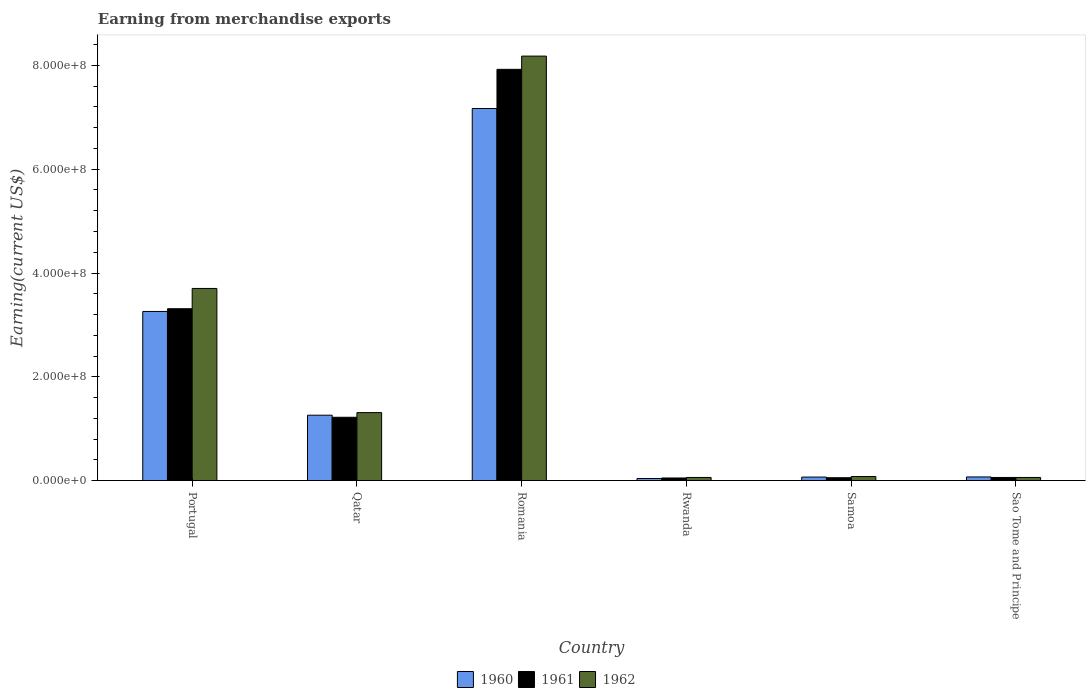How many different coloured bars are there?
Make the answer very short. 3. Are the number of bars per tick equal to the number of legend labels?
Ensure brevity in your answer.  Yes. How many bars are there on the 1st tick from the left?
Offer a very short reply. 3. What is the label of the 2nd group of bars from the left?
Provide a succinct answer. Qatar. What is the amount earned from merchandise exports in 1960 in Sao Tome and Principe?
Provide a succinct answer. 7.00e+06. Across all countries, what is the maximum amount earned from merchandise exports in 1961?
Offer a terse response. 7.92e+08. Across all countries, what is the minimum amount earned from merchandise exports in 1961?
Give a very brief answer. 5.00e+06. In which country was the amount earned from merchandise exports in 1961 maximum?
Provide a short and direct response. Romania. In which country was the amount earned from merchandise exports in 1962 minimum?
Your response must be concise. Rwanda. What is the total amount earned from merchandise exports in 1961 in the graph?
Ensure brevity in your answer.  1.26e+09. What is the difference between the amount earned from merchandise exports in 1961 in Portugal and that in Romania?
Your answer should be very brief. -4.61e+08. What is the difference between the amount earned from merchandise exports in 1961 in Romania and the amount earned from merchandise exports in 1962 in Rwanda?
Keep it short and to the point. 7.86e+08. What is the average amount earned from merchandise exports in 1961 per country?
Your answer should be compact. 2.10e+08. What is the difference between the amount earned from merchandise exports of/in 1960 and amount earned from merchandise exports of/in 1962 in Samoa?
Provide a short and direct response. -1.04e+06. What is the ratio of the amount earned from merchandise exports in 1961 in Qatar to that in Rwanda?
Offer a terse response. 24.4. Is the amount earned from merchandise exports in 1960 in Portugal less than that in Sao Tome and Principe?
Your answer should be very brief. No. What is the difference between the highest and the second highest amount earned from merchandise exports in 1962?
Provide a succinct answer. 4.48e+08. What is the difference between the highest and the lowest amount earned from merchandise exports in 1960?
Offer a very short reply. 7.13e+08. Is the sum of the amount earned from merchandise exports in 1960 in Portugal and Samoa greater than the maximum amount earned from merchandise exports in 1962 across all countries?
Your response must be concise. No. What does the 3rd bar from the left in Portugal represents?
Provide a succinct answer. 1962. What does the 1st bar from the right in Romania represents?
Offer a terse response. 1962. How many bars are there?
Provide a succinct answer. 18. Are all the bars in the graph horizontal?
Offer a terse response. No. What is the difference between two consecutive major ticks on the Y-axis?
Ensure brevity in your answer.  2.00e+08. Are the values on the major ticks of Y-axis written in scientific E-notation?
Your answer should be compact. Yes. Does the graph contain any zero values?
Your answer should be very brief. No. Does the graph contain grids?
Offer a terse response. No. How many legend labels are there?
Give a very brief answer. 3. What is the title of the graph?
Keep it short and to the point. Earning from merchandise exports. Does "1979" appear as one of the legend labels in the graph?
Your response must be concise. No. What is the label or title of the Y-axis?
Offer a terse response. Earning(current US$). What is the Earning(current US$) of 1960 in Portugal?
Your response must be concise. 3.26e+08. What is the Earning(current US$) of 1961 in Portugal?
Your response must be concise. 3.31e+08. What is the Earning(current US$) of 1962 in Portugal?
Your answer should be compact. 3.70e+08. What is the Earning(current US$) in 1960 in Qatar?
Ensure brevity in your answer.  1.26e+08. What is the Earning(current US$) of 1961 in Qatar?
Make the answer very short. 1.22e+08. What is the Earning(current US$) of 1962 in Qatar?
Your answer should be very brief. 1.31e+08. What is the Earning(current US$) in 1960 in Romania?
Ensure brevity in your answer.  7.17e+08. What is the Earning(current US$) of 1961 in Romania?
Offer a terse response. 7.92e+08. What is the Earning(current US$) of 1962 in Romania?
Ensure brevity in your answer.  8.18e+08. What is the Earning(current US$) of 1960 in Rwanda?
Your answer should be very brief. 4.00e+06. What is the Earning(current US$) of 1961 in Rwanda?
Make the answer very short. 5.00e+06. What is the Earning(current US$) of 1962 in Rwanda?
Give a very brief answer. 6.00e+06. What is the Earning(current US$) of 1960 in Samoa?
Offer a terse response. 6.77e+06. What is the Earning(current US$) of 1961 in Samoa?
Your response must be concise. 5.49e+06. What is the Earning(current US$) of 1962 in Samoa?
Your response must be concise. 7.80e+06. What is the Earning(current US$) of 1960 in Sao Tome and Principe?
Your answer should be compact. 7.00e+06. Across all countries, what is the maximum Earning(current US$) of 1960?
Offer a terse response. 7.17e+08. Across all countries, what is the maximum Earning(current US$) of 1961?
Your answer should be compact. 7.92e+08. Across all countries, what is the maximum Earning(current US$) of 1962?
Your answer should be compact. 8.18e+08. Across all countries, what is the minimum Earning(current US$) in 1960?
Your answer should be very brief. 4.00e+06. Across all countries, what is the minimum Earning(current US$) in 1961?
Offer a very short reply. 5.00e+06. Across all countries, what is the minimum Earning(current US$) of 1962?
Your answer should be compact. 6.00e+06. What is the total Earning(current US$) of 1960 in the graph?
Offer a terse response. 1.19e+09. What is the total Earning(current US$) of 1961 in the graph?
Keep it short and to the point. 1.26e+09. What is the total Earning(current US$) of 1962 in the graph?
Provide a short and direct response. 1.34e+09. What is the difference between the Earning(current US$) of 1960 in Portugal and that in Qatar?
Your response must be concise. 2.00e+08. What is the difference between the Earning(current US$) in 1961 in Portugal and that in Qatar?
Your response must be concise. 2.09e+08. What is the difference between the Earning(current US$) of 1962 in Portugal and that in Qatar?
Your answer should be very brief. 2.39e+08. What is the difference between the Earning(current US$) in 1960 in Portugal and that in Romania?
Provide a short and direct response. -3.91e+08. What is the difference between the Earning(current US$) in 1961 in Portugal and that in Romania?
Offer a very short reply. -4.61e+08. What is the difference between the Earning(current US$) in 1962 in Portugal and that in Romania?
Your answer should be very brief. -4.48e+08. What is the difference between the Earning(current US$) in 1960 in Portugal and that in Rwanda?
Provide a succinct answer. 3.22e+08. What is the difference between the Earning(current US$) in 1961 in Portugal and that in Rwanda?
Make the answer very short. 3.26e+08. What is the difference between the Earning(current US$) of 1962 in Portugal and that in Rwanda?
Provide a short and direct response. 3.64e+08. What is the difference between the Earning(current US$) in 1960 in Portugal and that in Samoa?
Your answer should be compact. 3.19e+08. What is the difference between the Earning(current US$) in 1961 in Portugal and that in Samoa?
Provide a succinct answer. 3.26e+08. What is the difference between the Earning(current US$) in 1962 in Portugal and that in Samoa?
Provide a succinct answer. 3.62e+08. What is the difference between the Earning(current US$) in 1960 in Portugal and that in Sao Tome and Principe?
Your answer should be compact. 3.19e+08. What is the difference between the Earning(current US$) of 1961 in Portugal and that in Sao Tome and Principe?
Ensure brevity in your answer.  3.25e+08. What is the difference between the Earning(current US$) of 1962 in Portugal and that in Sao Tome and Principe?
Your answer should be compact. 3.64e+08. What is the difference between the Earning(current US$) of 1960 in Qatar and that in Romania?
Offer a terse response. -5.91e+08. What is the difference between the Earning(current US$) of 1961 in Qatar and that in Romania?
Provide a short and direct response. -6.70e+08. What is the difference between the Earning(current US$) in 1962 in Qatar and that in Romania?
Ensure brevity in your answer.  -6.87e+08. What is the difference between the Earning(current US$) of 1960 in Qatar and that in Rwanda?
Offer a very short reply. 1.22e+08. What is the difference between the Earning(current US$) in 1961 in Qatar and that in Rwanda?
Provide a succinct answer. 1.17e+08. What is the difference between the Earning(current US$) in 1962 in Qatar and that in Rwanda?
Keep it short and to the point. 1.25e+08. What is the difference between the Earning(current US$) in 1960 in Qatar and that in Samoa?
Your answer should be very brief. 1.19e+08. What is the difference between the Earning(current US$) in 1961 in Qatar and that in Samoa?
Ensure brevity in your answer.  1.17e+08. What is the difference between the Earning(current US$) of 1962 in Qatar and that in Samoa?
Offer a terse response. 1.23e+08. What is the difference between the Earning(current US$) of 1960 in Qatar and that in Sao Tome and Principe?
Your answer should be very brief. 1.19e+08. What is the difference between the Earning(current US$) in 1961 in Qatar and that in Sao Tome and Principe?
Provide a succinct answer. 1.16e+08. What is the difference between the Earning(current US$) of 1962 in Qatar and that in Sao Tome and Principe?
Keep it short and to the point. 1.25e+08. What is the difference between the Earning(current US$) of 1960 in Romania and that in Rwanda?
Your answer should be very brief. 7.13e+08. What is the difference between the Earning(current US$) in 1961 in Romania and that in Rwanda?
Give a very brief answer. 7.88e+08. What is the difference between the Earning(current US$) in 1962 in Romania and that in Rwanda?
Your answer should be very brief. 8.12e+08. What is the difference between the Earning(current US$) of 1960 in Romania and that in Samoa?
Ensure brevity in your answer.  7.10e+08. What is the difference between the Earning(current US$) of 1961 in Romania and that in Samoa?
Offer a terse response. 7.87e+08. What is the difference between the Earning(current US$) of 1962 in Romania and that in Samoa?
Provide a short and direct response. 8.10e+08. What is the difference between the Earning(current US$) of 1960 in Romania and that in Sao Tome and Principe?
Your response must be concise. 7.10e+08. What is the difference between the Earning(current US$) in 1961 in Romania and that in Sao Tome and Principe?
Offer a very short reply. 7.86e+08. What is the difference between the Earning(current US$) in 1962 in Romania and that in Sao Tome and Principe?
Your response must be concise. 8.12e+08. What is the difference between the Earning(current US$) in 1960 in Rwanda and that in Samoa?
Your response must be concise. -2.77e+06. What is the difference between the Earning(current US$) of 1961 in Rwanda and that in Samoa?
Keep it short and to the point. -4.86e+05. What is the difference between the Earning(current US$) of 1962 in Rwanda and that in Samoa?
Provide a succinct answer. -1.80e+06. What is the difference between the Earning(current US$) of 1960 in Samoa and that in Sao Tome and Principe?
Keep it short and to the point. -2.32e+05. What is the difference between the Earning(current US$) in 1961 in Samoa and that in Sao Tome and Principe?
Your response must be concise. -5.14e+05. What is the difference between the Earning(current US$) in 1962 in Samoa and that in Sao Tome and Principe?
Provide a succinct answer. 1.80e+06. What is the difference between the Earning(current US$) in 1960 in Portugal and the Earning(current US$) in 1961 in Qatar?
Give a very brief answer. 2.04e+08. What is the difference between the Earning(current US$) in 1960 in Portugal and the Earning(current US$) in 1962 in Qatar?
Your answer should be compact. 1.95e+08. What is the difference between the Earning(current US$) in 1961 in Portugal and the Earning(current US$) in 1962 in Qatar?
Give a very brief answer. 2.00e+08. What is the difference between the Earning(current US$) of 1960 in Portugal and the Earning(current US$) of 1961 in Romania?
Provide a short and direct response. -4.67e+08. What is the difference between the Earning(current US$) of 1960 in Portugal and the Earning(current US$) of 1962 in Romania?
Your response must be concise. -4.92e+08. What is the difference between the Earning(current US$) of 1961 in Portugal and the Earning(current US$) of 1962 in Romania?
Ensure brevity in your answer.  -4.87e+08. What is the difference between the Earning(current US$) in 1960 in Portugal and the Earning(current US$) in 1961 in Rwanda?
Give a very brief answer. 3.21e+08. What is the difference between the Earning(current US$) of 1960 in Portugal and the Earning(current US$) of 1962 in Rwanda?
Offer a very short reply. 3.20e+08. What is the difference between the Earning(current US$) in 1961 in Portugal and the Earning(current US$) in 1962 in Rwanda?
Provide a short and direct response. 3.25e+08. What is the difference between the Earning(current US$) of 1960 in Portugal and the Earning(current US$) of 1961 in Samoa?
Provide a short and direct response. 3.20e+08. What is the difference between the Earning(current US$) in 1960 in Portugal and the Earning(current US$) in 1962 in Samoa?
Your answer should be compact. 3.18e+08. What is the difference between the Earning(current US$) in 1961 in Portugal and the Earning(current US$) in 1962 in Samoa?
Give a very brief answer. 3.23e+08. What is the difference between the Earning(current US$) in 1960 in Portugal and the Earning(current US$) in 1961 in Sao Tome and Principe?
Give a very brief answer. 3.20e+08. What is the difference between the Earning(current US$) in 1960 in Portugal and the Earning(current US$) in 1962 in Sao Tome and Principe?
Your response must be concise. 3.20e+08. What is the difference between the Earning(current US$) in 1961 in Portugal and the Earning(current US$) in 1962 in Sao Tome and Principe?
Your response must be concise. 3.25e+08. What is the difference between the Earning(current US$) of 1960 in Qatar and the Earning(current US$) of 1961 in Romania?
Ensure brevity in your answer.  -6.66e+08. What is the difference between the Earning(current US$) in 1960 in Qatar and the Earning(current US$) in 1962 in Romania?
Keep it short and to the point. -6.92e+08. What is the difference between the Earning(current US$) of 1961 in Qatar and the Earning(current US$) of 1962 in Romania?
Your answer should be compact. -6.96e+08. What is the difference between the Earning(current US$) in 1960 in Qatar and the Earning(current US$) in 1961 in Rwanda?
Offer a terse response. 1.21e+08. What is the difference between the Earning(current US$) of 1960 in Qatar and the Earning(current US$) of 1962 in Rwanda?
Keep it short and to the point. 1.20e+08. What is the difference between the Earning(current US$) of 1961 in Qatar and the Earning(current US$) of 1962 in Rwanda?
Provide a succinct answer. 1.16e+08. What is the difference between the Earning(current US$) in 1960 in Qatar and the Earning(current US$) in 1961 in Samoa?
Offer a terse response. 1.21e+08. What is the difference between the Earning(current US$) in 1960 in Qatar and the Earning(current US$) in 1962 in Samoa?
Provide a short and direct response. 1.18e+08. What is the difference between the Earning(current US$) in 1961 in Qatar and the Earning(current US$) in 1962 in Samoa?
Provide a short and direct response. 1.14e+08. What is the difference between the Earning(current US$) of 1960 in Qatar and the Earning(current US$) of 1961 in Sao Tome and Principe?
Offer a very short reply. 1.20e+08. What is the difference between the Earning(current US$) in 1960 in Qatar and the Earning(current US$) in 1962 in Sao Tome and Principe?
Keep it short and to the point. 1.20e+08. What is the difference between the Earning(current US$) of 1961 in Qatar and the Earning(current US$) of 1962 in Sao Tome and Principe?
Ensure brevity in your answer.  1.16e+08. What is the difference between the Earning(current US$) in 1960 in Romania and the Earning(current US$) in 1961 in Rwanda?
Offer a terse response. 7.12e+08. What is the difference between the Earning(current US$) in 1960 in Romania and the Earning(current US$) in 1962 in Rwanda?
Make the answer very short. 7.11e+08. What is the difference between the Earning(current US$) of 1961 in Romania and the Earning(current US$) of 1962 in Rwanda?
Your answer should be very brief. 7.86e+08. What is the difference between the Earning(current US$) in 1960 in Romania and the Earning(current US$) in 1961 in Samoa?
Give a very brief answer. 7.12e+08. What is the difference between the Earning(current US$) of 1960 in Romania and the Earning(current US$) of 1962 in Samoa?
Ensure brevity in your answer.  7.09e+08. What is the difference between the Earning(current US$) in 1961 in Romania and the Earning(current US$) in 1962 in Samoa?
Ensure brevity in your answer.  7.85e+08. What is the difference between the Earning(current US$) of 1960 in Romania and the Earning(current US$) of 1961 in Sao Tome and Principe?
Give a very brief answer. 7.11e+08. What is the difference between the Earning(current US$) in 1960 in Romania and the Earning(current US$) in 1962 in Sao Tome and Principe?
Your answer should be very brief. 7.11e+08. What is the difference between the Earning(current US$) of 1961 in Romania and the Earning(current US$) of 1962 in Sao Tome and Principe?
Provide a succinct answer. 7.86e+08. What is the difference between the Earning(current US$) in 1960 in Rwanda and the Earning(current US$) in 1961 in Samoa?
Your response must be concise. -1.49e+06. What is the difference between the Earning(current US$) of 1960 in Rwanda and the Earning(current US$) of 1962 in Samoa?
Offer a terse response. -3.80e+06. What is the difference between the Earning(current US$) in 1961 in Rwanda and the Earning(current US$) in 1962 in Samoa?
Provide a succinct answer. -2.80e+06. What is the difference between the Earning(current US$) in 1960 in Rwanda and the Earning(current US$) in 1961 in Sao Tome and Principe?
Ensure brevity in your answer.  -2.00e+06. What is the difference between the Earning(current US$) in 1960 in Samoa and the Earning(current US$) in 1961 in Sao Tome and Principe?
Your answer should be compact. 7.68e+05. What is the difference between the Earning(current US$) of 1960 in Samoa and the Earning(current US$) of 1962 in Sao Tome and Principe?
Your answer should be very brief. 7.68e+05. What is the difference between the Earning(current US$) of 1961 in Samoa and the Earning(current US$) of 1962 in Sao Tome and Principe?
Ensure brevity in your answer.  -5.14e+05. What is the average Earning(current US$) of 1960 per country?
Ensure brevity in your answer.  1.98e+08. What is the average Earning(current US$) in 1961 per country?
Your response must be concise. 2.10e+08. What is the average Earning(current US$) in 1962 per country?
Your answer should be very brief. 2.23e+08. What is the difference between the Earning(current US$) in 1960 and Earning(current US$) in 1961 in Portugal?
Your answer should be compact. -5.25e+06. What is the difference between the Earning(current US$) in 1960 and Earning(current US$) in 1962 in Portugal?
Your answer should be compact. -4.43e+07. What is the difference between the Earning(current US$) in 1961 and Earning(current US$) in 1962 in Portugal?
Your answer should be compact. -3.91e+07. What is the difference between the Earning(current US$) of 1960 and Earning(current US$) of 1961 in Qatar?
Offer a very short reply. 4.00e+06. What is the difference between the Earning(current US$) of 1960 and Earning(current US$) of 1962 in Qatar?
Provide a succinct answer. -5.00e+06. What is the difference between the Earning(current US$) in 1961 and Earning(current US$) in 1962 in Qatar?
Keep it short and to the point. -9.00e+06. What is the difference between the Earning(current US$) in 1960 and Earning(current US$) in 1961 in Romania?
Your answer should be compact. -7.55e+07. What is the difference between the Earning(current US$) of 1960 and Earning(current US$) of 1962 in Romania?
Offer a very short reply. -1.01e+08. What is the difference between the Earning(current US$) of 1961 and Earning(current US$) of 1962 in Romania?
Offer a very short reply. -2.55e+07. What is the difference between the Earning(current US$) of 1960 and Earning(current US$) of 1962 in Rwanda?
Offer a very short reply. -2.00e+06. What is the difference between the Earning(current US$) of 1961 and Earning(current US$) of 1962 in Rwanda?
Your response must be concise. -1.00e+06. What is the difference between the Earning(current US$) of 1960 and Earning(current US$) of 1961 in Samoa?
Provide a succinct answer. 1.28e+06. What is the difference between the Earning(current US$) of 1960 and Earning(current US$) of 1962 in Samoa?
Offer a very short reply. -1.04e+06. What is the difference between the Earning(current US$) in 1961 and Earning(current US$) in 1962 in Samoa?
Your answer should be compact. -2.32e+06. What is the difference between the Earning(current US$) in 1960 and Earning(current US$) in 1961 in Sao Tome and Principe?
Your answer should be very brief. 1.00e+06. What is the difference between the Earning(current US$) in 1960 and Earning(current US$) in 1962 in Sao Tome and Principe?
Give a very brief answer. 1.00e+06. What is the difference between the Earning(current US$) in 1961 and Earning(current US$) in 1962 in Sao Tome and Principe?
Ensure brevity in your answer.  0. What is the ratio of the Earning(current US$) in 1960 in Portugal to that in Qatar?
Your response must be concise. 2.59. What is the ratio of the Earning(current US$) in 1961 in Portugal to that in Qatar?
Offer a terse response. 2.71. What is the ratio of the Earning(current US$) of 1962 in Portugal to that in Qatar?
Provide a short and direct response. 2.83. What is the ratio of the Earning(current US$) in 1960 in Portugal to that in Romania?
Ensure brevity in your answer.  0.45. What is the ratio of the Earning(current US$) of 1961 in Portugal to that in Romania?
Offer a very short reply. 0.42. What is the ratio of the Earning(current US$) of 1962 in Portugal to that in Romania?
Ensure brevity in your answer.  0.45. What is the ratio of the Earning(current US$) of 1960 in Portugal to that in Rwanda?
Make the answer very short. 81.48. What is the ratio of the Earning(current US$) of 1961 in Portugal to that in Rwanda?
Provide a succinct answer. 66.23. What is the ratio of the Earning(current US$) of 1962 in Portugal to that in Rwanda?
Ensure brevity in your answer.  61.71. What is the ratio of the Earning(current US$) in 1960 in Portugal to that in Samoa?
Offer a very short reply. 48.16. What is the ratio of the Earning(current US$) of 1961 in Portugal to that in Samoa?
Keep it short and to the point. 60.37. What is the ratio of the Earning(current US$) in 1962 in Portugal to that in Samoa?
Ensure brevity in your answer.  47.44. What is the ratio of the Earning(current US$) of 1960 in Portugal to that in Sao Tome and Principe?
Provide a short and direct response. 46.56. What is the ratio of the Earning(current US$) of 1961 in Portugal to that in Sao Tome and Principe?
Offer a terse response. 55.19. What is the ratio of the Earning(current US$) in 1962 in Portugal to that in Sao Tome and Principe?
Your answer should be compact. 61.71. What is the ratio of the Earning(current US$) of 1960 in Qatar to that in Romania?
Make the answer very short. 0.18. What is the ratio of the Earning(current US$) in 1961 in Qatar to that in Romania?
Keep it short and to the point. 0.15. What is the ratio of the Earning(current US$) in 1962 in Qatar to that in Romania?
Provide a short and direct response. 0.16. What is the ratio of the Earning(current US$) of 1960 in Qatar to that in Rwanda?
Offer a very short reply. 31.5. What is the ratio of the Earning(current US$) of 1961 in Qatar to that in Rwanda?
Offer a very short reply. 24.4. What is the ratio of the Earning(current US$) of 1962 in Qatar to that in Rwanda?
Make the answer very short. 21.83. What is the ratio of the Earning(current US$) in 1960 in Qatar to that in Samoa?
Keep it short and to the point. 18.62. What is the ratio of the Earning(current US$) in 1961 in Qatar to that in Samoa?
Provide a succinct answer. 22.24. What is the ratio of the Earning(current US$) of 1962 in Qatar to that in Samoa?
Give a very brief answer. 16.79. What is the ratio of the Earning(current US$) in 1961 in Qatar to that in Sao Tome and Principe?
Ensure brevity in your answer.  20.33. What is the ratio of the Earning(current US$) in 1962 in Qatar to that in Sao Tome and Principe?
Your response must be concise. 21.83. What is the ratio of the Earning(current US$) of 1960 in Romania to that in Rwanda?
Give a very brief answer. 179.25. What is the ratio of the Earning(current US$) of 1961 in Romania to that in Rwanda?
Offer a very short reply. 158.5. What is the ratio of the Earning(current US$) of 1962 in Romania to that in Rwanda?
Give a very brief answer. 136.33. What is the ratio of the Earning(current US$) in 1960 in Romania to that in Samoa?
Make the answer very short. 105.95. What is the ratio of the Earning(current US$) of 1961 in Romania to that in Samoa?
Ensure brevity in your answer.  144.47. What is the ratio of the Earning(current US$) of 1962 in Romania to that in Samoa?
Your response must be concise. 104.81. What is the ratio of the Earning(current US$) of 1960 in Romania to that in Sao Tome and Principe?
Offer a very short reply. 102.43. What is the ratio of the Earning(current US$) in 1961 in Romania to that in Sao Tome and Principe?
Make the answer very short. 132.08. What is the ratio of the Earning(current US$) in 1962 in Romania to that in Sao Tome and Principe?
Provide a short and direct response. 136.33. What is the ratio of the Earning(current US$) in 1960 in Rwanda to that in Samoa?
Your response must be concise. 0.59. What is the ratio of the Earning(current US$) in 1961 in Rwanda to that in Samoa?
Your answer should be compact. 0.91. What is the ratio of the Earning(current US$) in 1962 in Rwanda to that in Samoa?
Offer a very short reply. 0.77. What is the ratio of the Earning(current US$) in 1961 in Rwanda to that in Sao Tome and Principe?
Your response must be concise. 0.83. What is the ratio of the Earning(current US$) of 1962 in Rwanda to that in Sao Tome and Principe?
Your answer should be compact. 1. What is the ratio of the Earning(current US$) of 1960 in Samoa to that in Sao Tome and Principe?
Make the answer very short. 0.97. What is the ratio of the Earning(current US$) in 1961 in Samoa to that in Sao Tome and Principe?
Your response must be concise. 0.91. What is the ratio of the Earning(current US$) in 1962 in Samoa to that in Sao Tome and Principe?
Provide a succinct answer. 1.3. What is the difference between the highest and the second highest Earning(current US$) of 1960?
Offer a terse response. 3.91e+08. What is the difference between the highest and the second highest Earning(current US$) in 1961?
Ensure brevity in your answer.  4.61e+08. What is the difference between the highest and the second highest Earning(current US$) of 1962?
Your response must be concise. 4.48e+08. What is the difference between the highest and the lowest Earning(current US$) of 1960?
Provide a short and direct response. 7.13e+08. What is the difference between the highest and the lowest Earning(current US$) of 1961?
Your answer should be compact. 7.88e+08. What is the difference between the highest and the lowest Earning(current US$) in 1962?
Your response must be concise. 8.12e+08. 